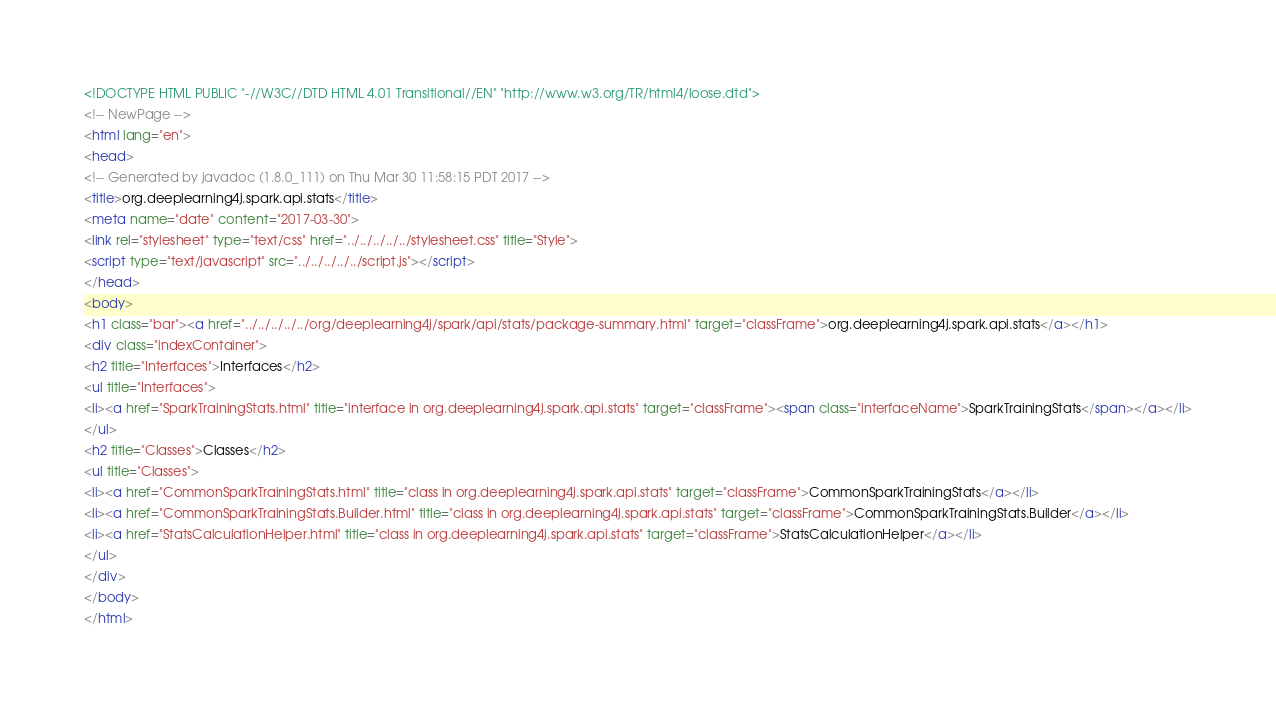Convert code to text. <code><loc_0><loc_0><loc_500><loc_500><_HTML_><!DOCTYPE HTML PUBLIC "-//W3C//DTD HTML 4.01 Transitional//EN" "http://www.w3.org/TR/html4/loose.dtd">
<!-- NewPage -->
<html lang="en">
<head>
<!-- Generated by javadoc (1.8.0_111) on Thu Mar 30 11:58:15 PDT 2017 -->
<title>org.deeplearning4j.spark.api.stats</title>
<meta name="date" content="2017-03-30">
<link rel="stylesheet" type="text/css" href="../../../../../stylesheet.css" title="Style">
<script type="text/javascript" src="../../../../../script.js"></script>
</head>
<body>
<h1 class="bar"><a href="../../../../../org/deeplearning4j/spark/api/stats/package-summary.html" target="classFrame">org.deeplearning4j.spark.api.stats</a></h1>
<div class="indexContainer">
<h2 title="Interfaces">Interfaces</h2>
<ul title="Interfaces">
<li><a href="SparkTrainingStats.html" title="interface in org.deeplearning4j.spark.api.stats" target="classFrame"><span class="interfaceName">SparkTrainingStats</span></a></li>
</ul>
<h2 title="Classes">Classes</h2>
<ul title="Classes">
<li><a href="CommonSparkTrainingStats.html" title="class in org.deeplearning4j.spark.api.stats" target="classFrame">CommonSparkTrainingStats</a></li>
<li><a href="CommonSparkTrainingStats.Builder.html" title="class in org.deeplearning4j.spark.api.stats" target="classFrame">CommonSparkTrainingStats.Builder</a></li>
<li><a href="StatsCalculationHelper.html" title="class in org.deeplearning4j.spark.api.stats" target="classFrame">StatsCalculationHelper</a></li>
</ul>
</div>
</body>
</html>
</code> 